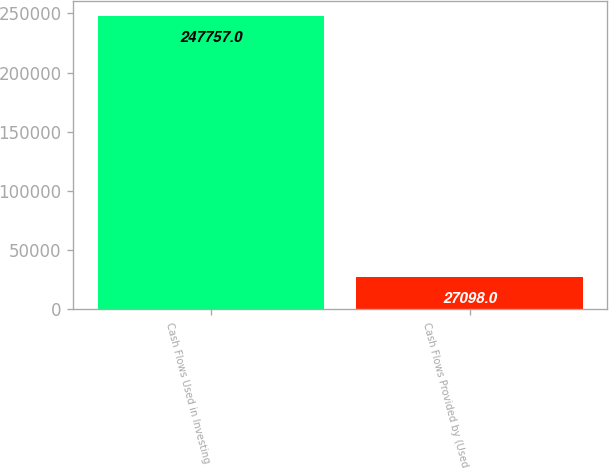Convert chart to OTSL. <chart><loc_0><loc_0><loc_500><loc_500><bar_chart><fcel>Cash Flows Used in Investing<fcel>Cash Flows Provided by (Used<nl><fcel>247757<fcel>27098<nl></chart> 